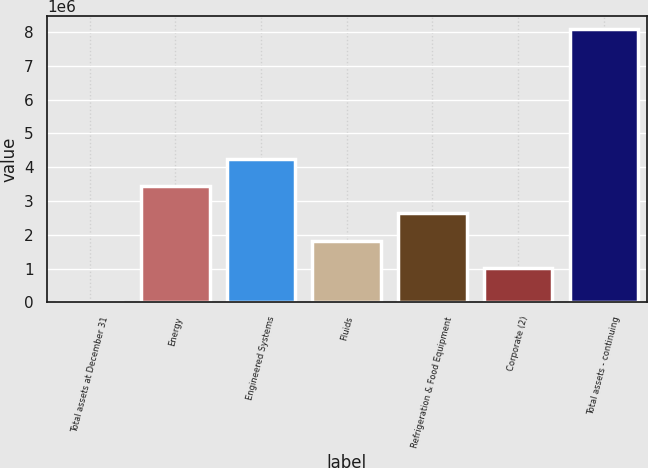Convert chart. <chart><loc_0><loc_0><loc_500><loc_500><bar_chart><fcel>Total assets at December 31<fcel>Energy<fcel>Engineered Systems<fcel>Fluids<fcel>Refrigeration & Food Equipment<fcel>Corporate (2)<fcel>Total assets - continuing<nl><fcel>2013<fcel>3.44156e+06<fcel>4.24897e+06<fcel>1.82674e+06<fcel>2.63415e+06<fcel>1.01933e+06<fcel>8.07612e+06<nl></chart> 